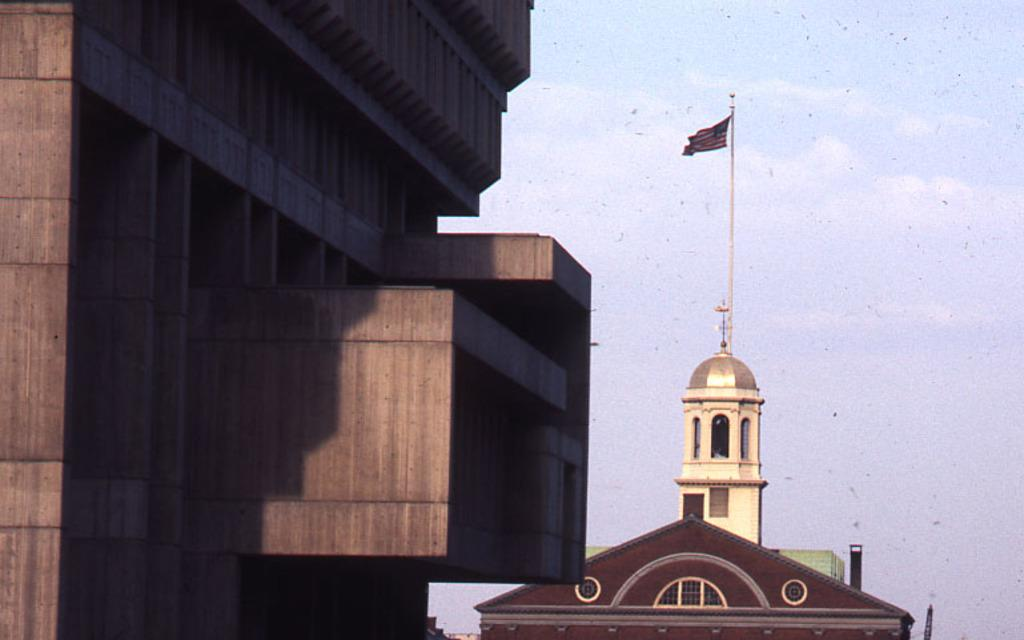What type of structures are present in the image? There are buildings in the image. Is there any symbol or object related to a country or organization in the image? Yes, there is a flag in the image. Where is the flag located in the image? The flag is at the top of the image. What type of profit can be seen from the machine in the image? There is no machine present in the image, so it is not possible to determine any profit. 